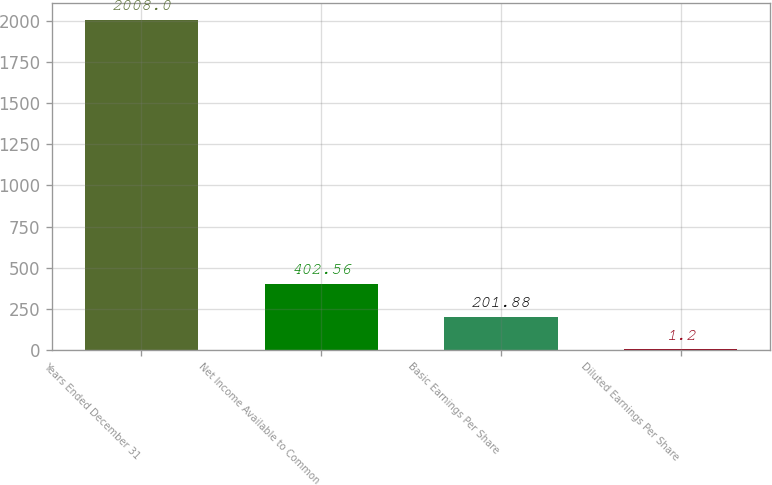Convert chart to OTSL. <chart><loc_0><loc_0><loc_500><loc_500><bar_chart><fcel>Years Ended December 31<fcel>Net Income Available to Common<fcel>Basic Earnings Per Share<fcel>Diluted Earnings Per Share<nl><fcel>2008<fcel>402.56<fcel>201.88<fcel>1.2<nl></chart> 